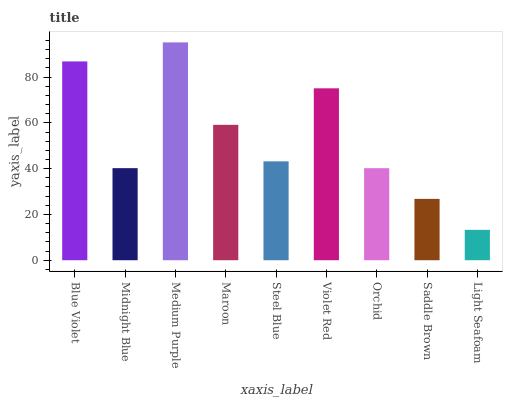Is Light Seafoam the minimum?
Answer yes or no. Yes. Is Medium Purple the maximum?
Answer yes or no. Yes. Is Midnight Blue the minimum?
Answer yes or no. No. Is Midnight Blue the maximum?
Answer yes or no. No. Is Blue Violet greater than Midnight Blue?
Answer yes or no. Yes. Is Midnight Blue less than Blue Violet?
Answer yes or no. Yes. Is Midnight Blue greater than Blue Violet?
Answer yes or no. No. Is Blue Violet less than Midnight Blue?
Answer yes or no. No. Is Steel Blue the high median?
Answer yes or no. Yes. Is Steel Blue the low median?
Answer yes or no. Yes. Is Light Seafoam the high median?
Answer yes or no. No. Is Light Seafoam the low median?
Answer yes or no. No. 